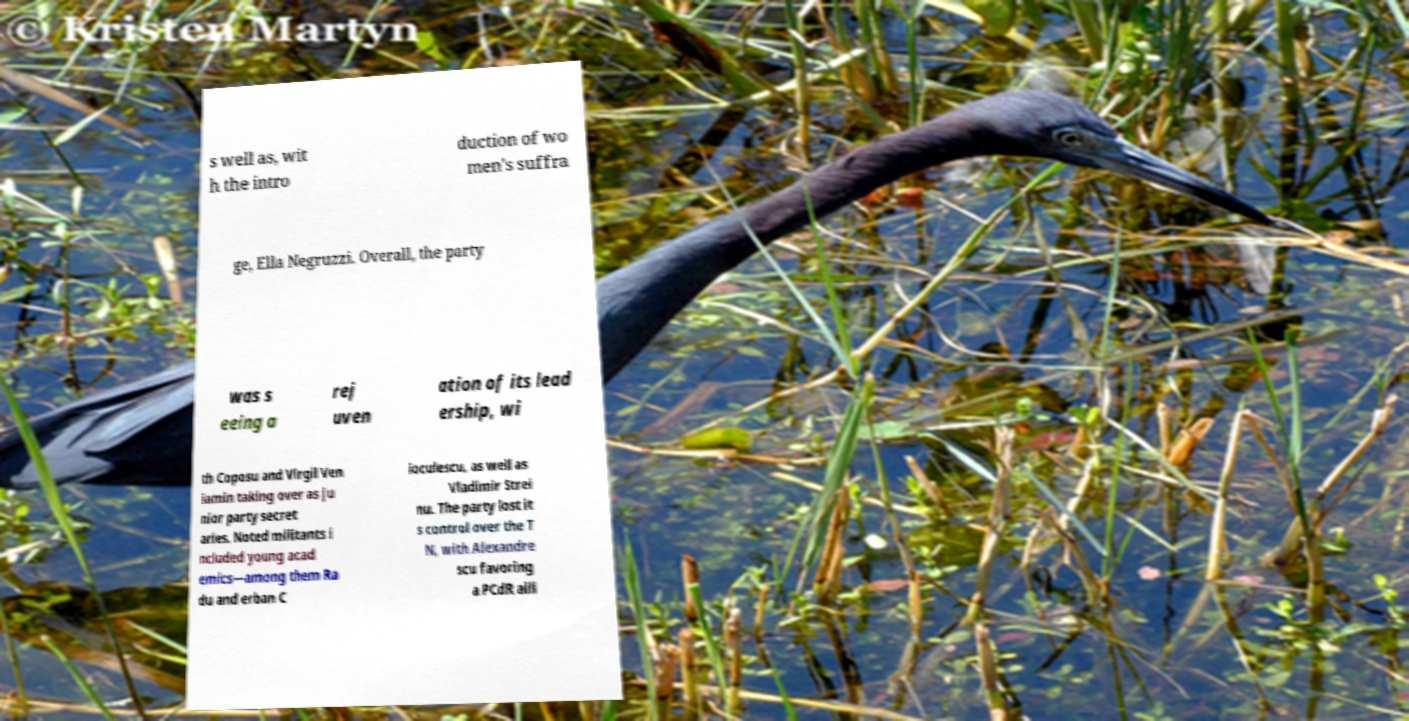I need the written content from this picture converted into text. Can you do that? s well as, wit h the intro duction of wo men's suffra ge, Ella Negruzzi. Overall, the party was s eeing a rej uven ation of its lead ership, wi th Coposu and Virgil Ven iamin taking over as ju nior party secret aries. Noted militants i ncluded young acad emics—among them Ra du and erban C ioculescu, as well as Vladimir Strei nu. The party lost it s control over the T N, with Alexandre scu favoring a PCdR alli 